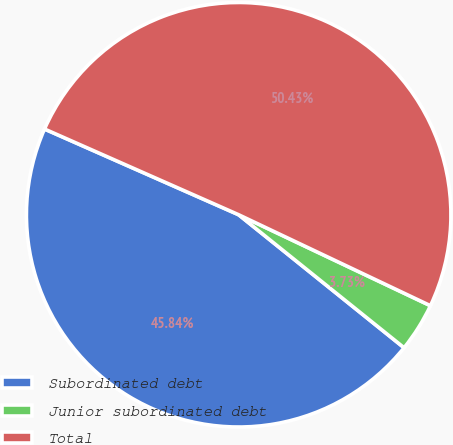Convert chart to OTSL. <chart><loc_0><loc_0><loc_500><loc_500><pie_chart><fcel>Subordinated debt<fcel>Junior subordinated debt<fcel>Total<nl><fcel>45.84%<fcel>3.73%<fcel>50.43%<nl></chart> 